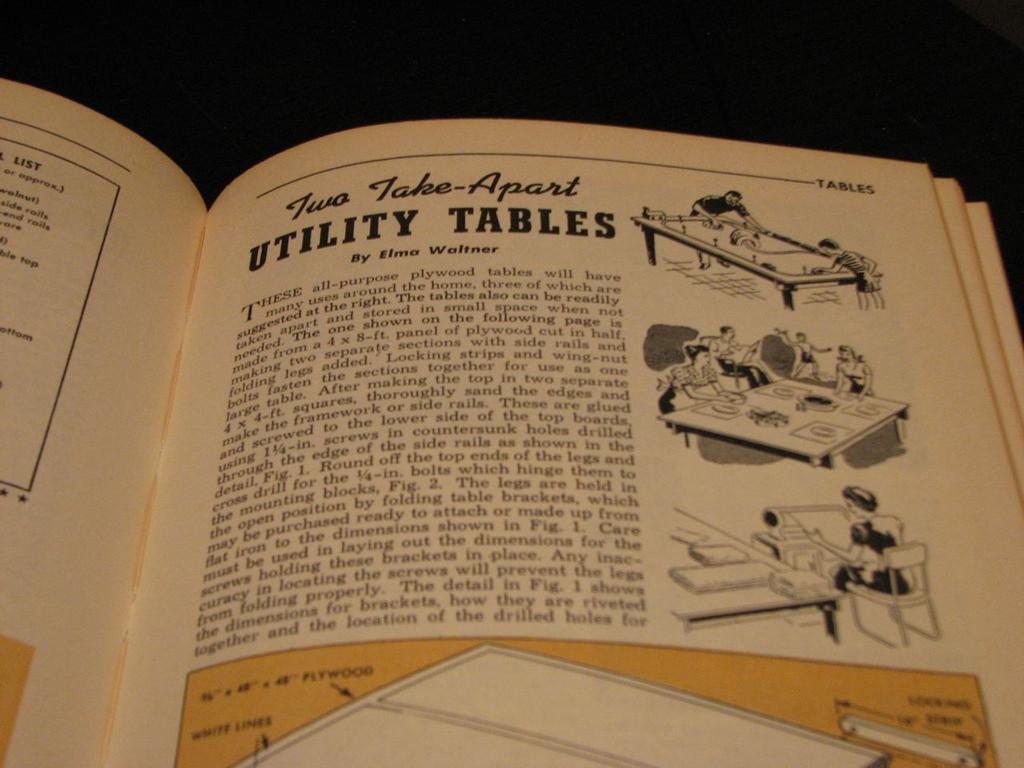What is the title of this activity in this book?
Offer a very short reply. Two take-apart utility tables. 